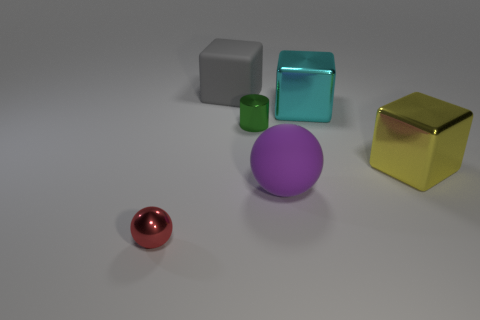Do the big purple thing and the large matte object left of the cylinder have the same shape?
Make the answer very short. No. Is the shape of the small thing that is to the right of the big rubber block the same as  the large yellow shiny object?
Keep it short and to the point. No. What number of shiny objects are both in front of the large cyan metal object and on the right side of the tiny metallic ball?
Offer a very short reply. 2. What number of other objects are there of the same size as the yellow metallic cube?
Your answer should be compact. 3. Is the number of spheres right of the large cyan metallic object the same as the number of metal objects?
Give a very brief answer. No. Does the big metal cube to the right of the big cyan block have the same color as the large rubber object on the right side of the gray rubber thing?
Your answer should be very brief. No. The large thing that is on the left side of the cyan thing and in front of the large gray matte cube is made of what material?
Keep it short and to the point. Rubber. The big matte cube is what color?
Keep it short and to the point. Gray. How many other things are there of the same shape as the tiny green thing?
Keep it short and to the point. 0. Are there the same number of big metal things left of the small green cylinder and cyan metallic things that are in front of the big yellow metal block?
Your answer should be very brief. Yes. 